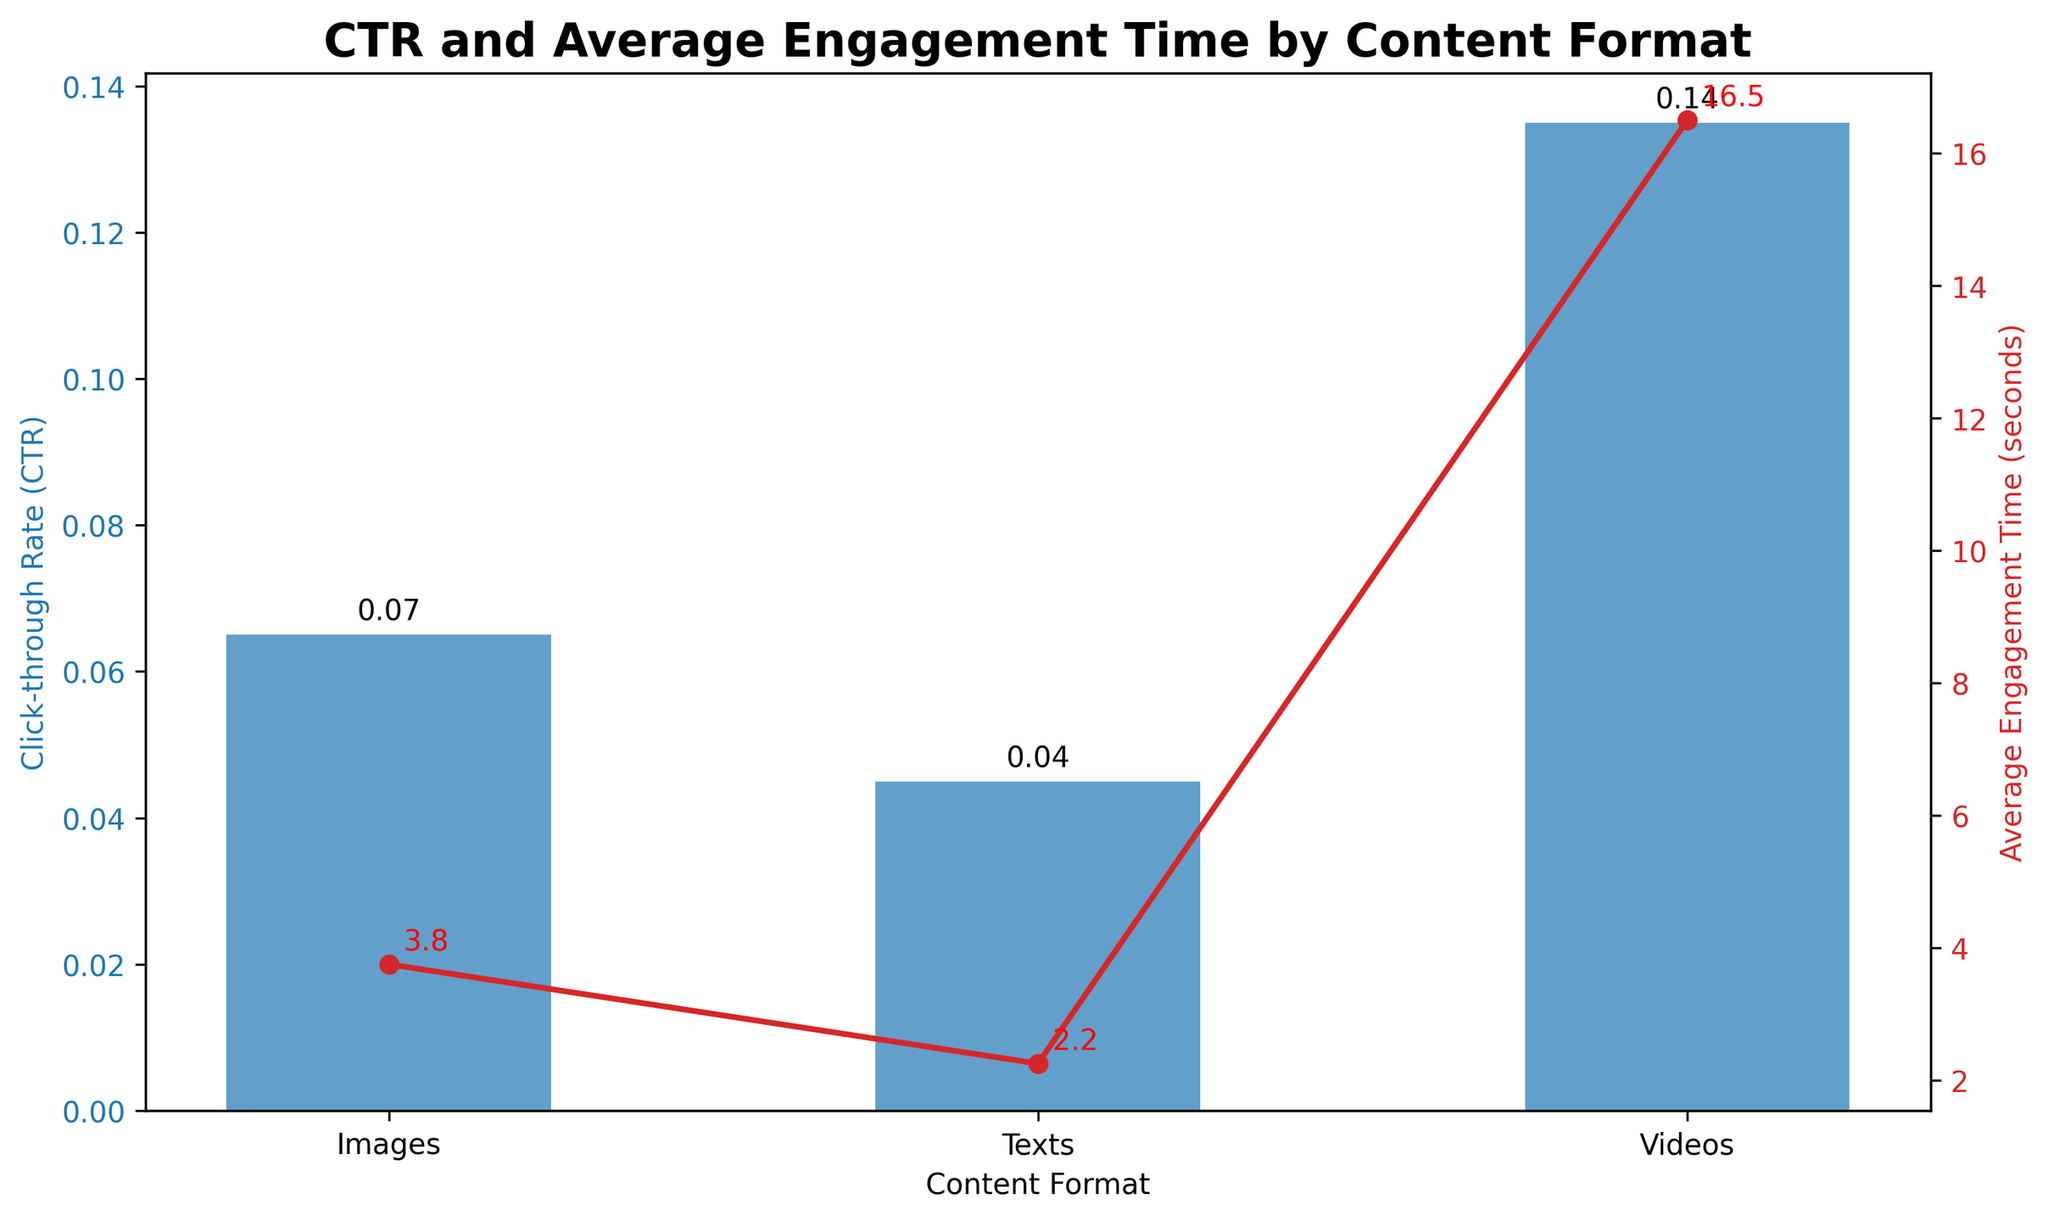Which content format has the highest Click-through Rate (CTR)? The blue bars represent the CTR for each content format. The bar for Videos is the highest among all content formats.
Answer: Videos Which content format has the lowest average engagement time? The red line represents the average engagement time. The point representing Texts is the lowest along this line.
Answer: Texts What is the difference between the highest and lowest CTRs? The highest CTR (for Videos) is around 0.14, and the lowest CTR (for Texts) is around 0.04. The difference is 0.14 - 0.04 = 0.10.
Answer: 0.10 How does the average engagement time compare between Images and Texts? Looking at the red line, the average engagement time for Images is higher than that for Texts.
Answer: Higher for Images What is the average CTR for all content formats? To find the average CTR, add the CTRs of all formats ( Videos: ~0.135, Images: ~0.065, Texts: ~0.045) and divide by 3. (0.135 + 0.065 + 0.045) / 3 = ~0.081.
Answer: ~0.081 Compare the average engagement time for Videos and Images. Which one is higher and by how much? The average engagement time for Videos is about 16.5 seconds, and for Images, it’s about 4.0 seconds. The difference is 16.5 - 4.0 = 12.5 seconds.
Answer: Videos by 12.5 seconds Which content format shows the greatest variation in CTR? Observe the heights of the blue bars. The Video format has the widest range from lowest to highest CTR (0.12 to 0.15), indicating the greatest variation.
Answer: Videos What is the average engagement time across all content formats? Sum the average engagement times ( Videos: 16.5, Images: 4.0, Texts: 2.25) and divide by 3. (16.5 + 4.0 + 2.25) / 3 = 7.58 seconds.
Answer: 7.58 seconds Which content format is closest in CTR to Images? The CTR for Images is around 0.065. Looking at the blue bars, Texts have a CTR close to 0.05, which is closer than Videos.
Answer: Texts 